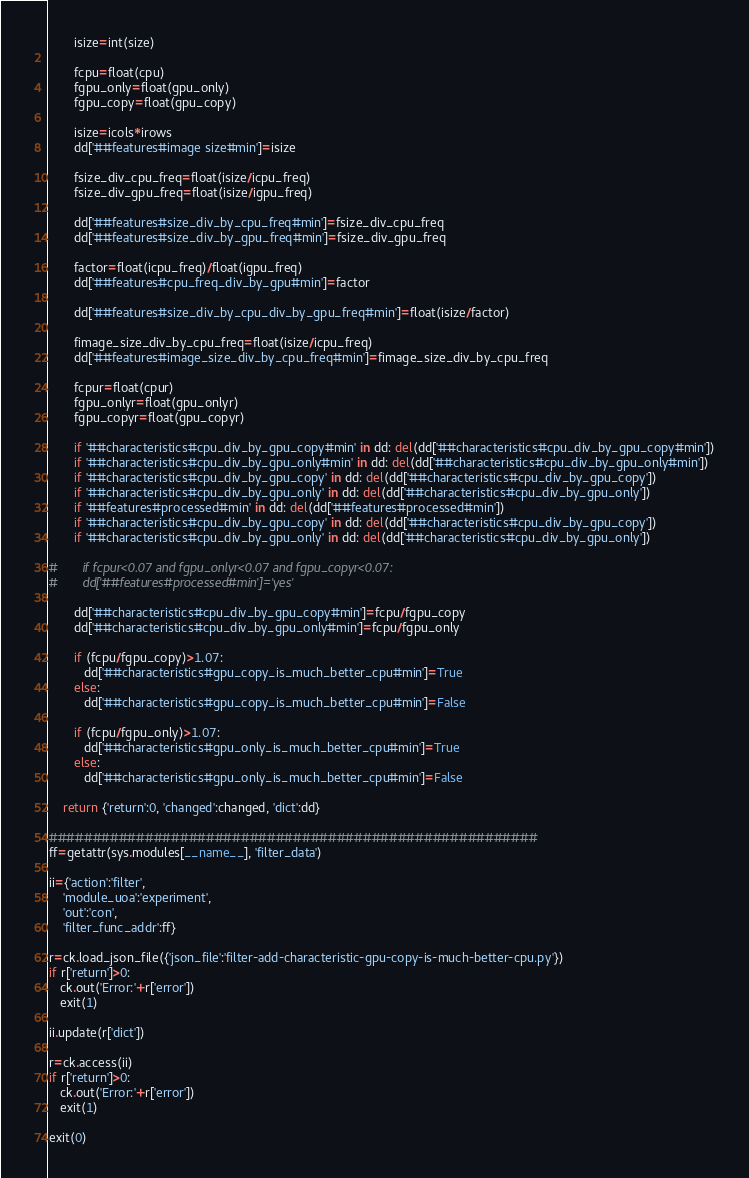Convert code to text. <code><loc_0><loc_0><loc_500><loc_500><_Python_>       isize=int(size)

       fcpu=float(cpu)
       fgpu_only=float(gpu_only)
       fgpu_copy=float(gpu_copy)

       isize=icols*irows
       dd['##features#image size#min']=isize

       fsize_div_cpu_freq=float(isize/icpu_freq)
       fsize_div_gpu_freq=float(isize/igpu_freq)

       dd['##features#size_div_by_cpu_freq#min']=fsize_div_cpu_freq
       dd['##features#size_div_by_gpu_freq#min']=fsize_div_gpu_freq

       factor=float(icpu_freq)/float(igpu_freq)
       dd['##features#cpu_freq_div_by_gpu#min']=factor

       dd['##features#size_div_by_cpu_div_by_gpu_freq#min']=float(isize/factor)

       fimage_size_div_by_cpu_freq=float(isize/icpu_freq)
       dd['##features#image_size_div_by_cpu_freq#min']=fimage_size_div_by_cpu_freq

       fcpur=float(cpur)
       fgpu_onlyr=float(gpu_onlyr)
       fgpu_copyr=float(gpu_copyr)

       if '##characteristics#cpu_div_by_gpu_copy#min' in dd: del(dd['##characteristics#cpu_div_by_gpu_copy#min'])
       if '##characteristics#cpu_div_by_gpu_only#min' in dd: del(dd['##characteristics#cpu_div_by_gpu_only#min'])
       if '##characteristics#cpu_div_by_gpu_copy' in dd: del(dd['##characteristics#cpu_div_by_gpu_copy'])
       if '##characteristics#cpu_div_by_gpu_only' in dd: del(dd['##characteristics#cpu_div_by_gpu_only'])
       if '##features#processed#min' in dd: del(dd['##features#processed#min'])
       if '##characteristics#cpu_div_by_gpu_copy' in dd: del(dd['##characteristics#cpu_div_by_gpu_copy'])
       if '##characteristics#cpu_div_by_gpu_only' in dd: del(dd['##characteristics#cpu_div_by_gpu_only'])

#       if fcpur<0.07 and fgpu_onlyr<0.07 and fgpu_copyr<0.07:
#       dd['##features#processed#min']='yes'

       dd['##characteristics#cpu_div_by_gpu_copy#min']=fcpu/fgpu_copy
       dd['##characteristics#cpu_div_by_gpu_only#min']=fcpu/fgpu_only
       
       if (fcpu/fgpu_copy)>1.07:
          dd['##characteristics#gpu_copy_is_much_better_cpu#min']=True
       else:
          dd['##characteristics#gpu_copy_is_much_better_cpu#min']=False

       if (fcpu/fgpu_only)>1.07:
          dd['##characteristics#gpu_only_is_much_better_cpu#min']=True
       else:
          dd['##characteristics#gpu_only_is_much_better_cpu#min']=False

    return {'return':0, 'changed':changed, 'dict':dd}

########################################################
ff=getattr(sys.modules[__name__], 'filter_data')

ii={'action':'filter',
    'module_uoa':'experiment',
    'out':'con',
    'filter_func_addr':ff}

r=ck.load_json_file({'json_file':'filter-add-characteristic-gpu-copy-is-much-better-cpu.py'})
if r['return']>0: 
   ck.out('Error:'+r['error'])
   exit(1)

ii.update(r['dict'])

r=ck.access(ii)
if r['return']>0: 
   ck.out('Error:'+r['error'])
   exit(1)

exit(0)
</code> 